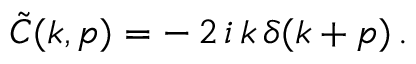<formula> <loc_0><loc_0><loc_500><loc_500>\tilde { C } ( k , p ) = - \, 2 \, i \, k \, \delta ( k + p ) \, .</formula> 